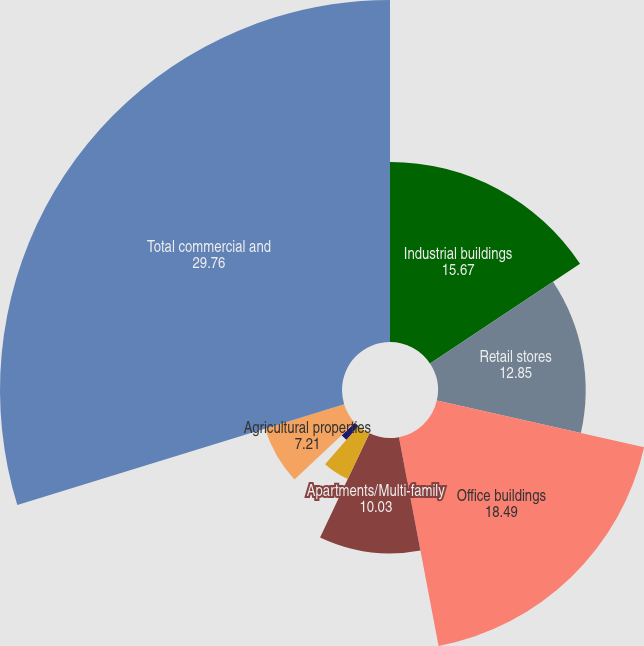Convert chart. <chart><loc_0><loc_0><loc_500><loc_500><pie_chart><fcel>Industrial buildings<fcel>Retail stores<fcel>Office buildings<fcel>Apartments/Multi-family<fcel>Other<fcel>Hospitality<fcel>Agricultural properties<fcel>Total commercial and<nl><fcel>15.67%<fcel>12.85%<fcel>18.49%<fcel>10.03%<fcel>4.4%<fcel>1.58%<fcel>7.21%<fcel>29.76%<nl></chart> 